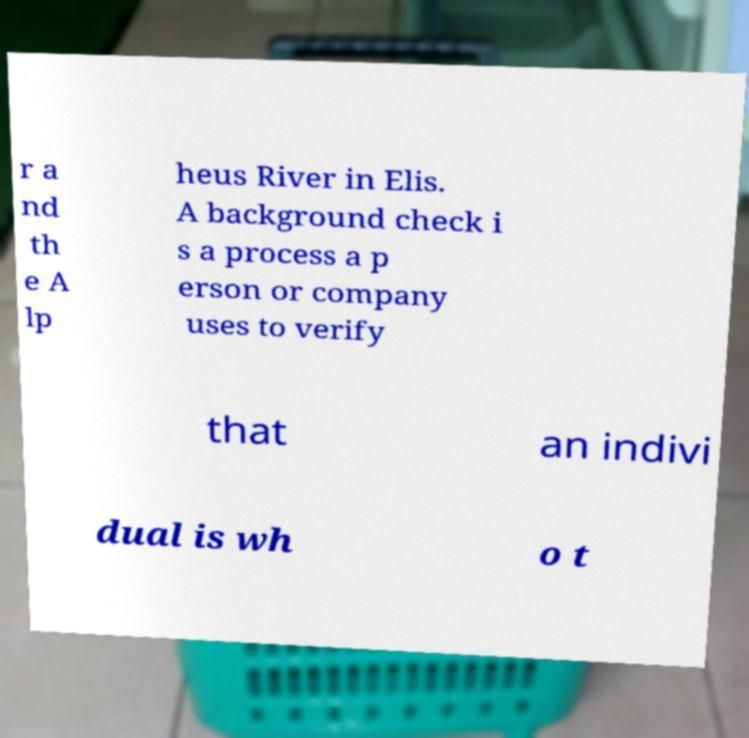Can you accurately transcribe the text from the provided image for me? r a nd th e A lp heus River in Elis. A background check i s a process a p erson or company uses to verify that an indivi dual is wh o t 